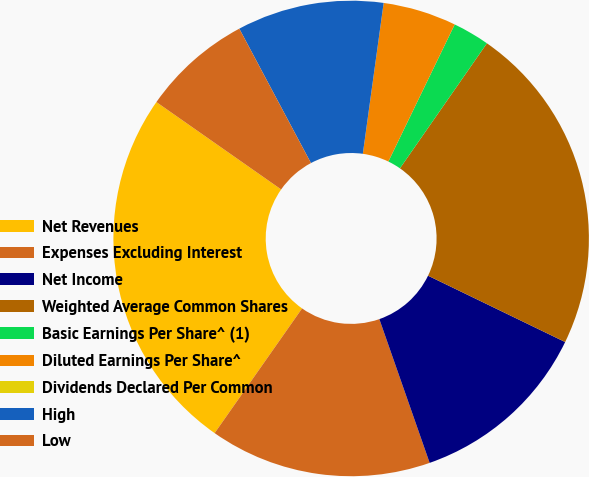Convert chart. <chart><loc_0><loc_0><loc_500><loc_500><pie_chart><fcel>Net Revenues<fcel>Expenses Excluding Interest<fcel>Net Income<fcel>Weighted Average Common Shares<fcel>Basic Earnings Per Share^ (1)<fcel>Diluted Earnings Per Share^<fcel>Dividends Declared Per Common<fcel>High<fcel>Low<nl><fcel>24.99%<fcel>15.09%<fcel>12.47%<fcel>22.5%<fcel>2.5%<fcel>4.99%<fcel>0.0%<fcel>9.98%<fcel>7.48%<nl></chart> 